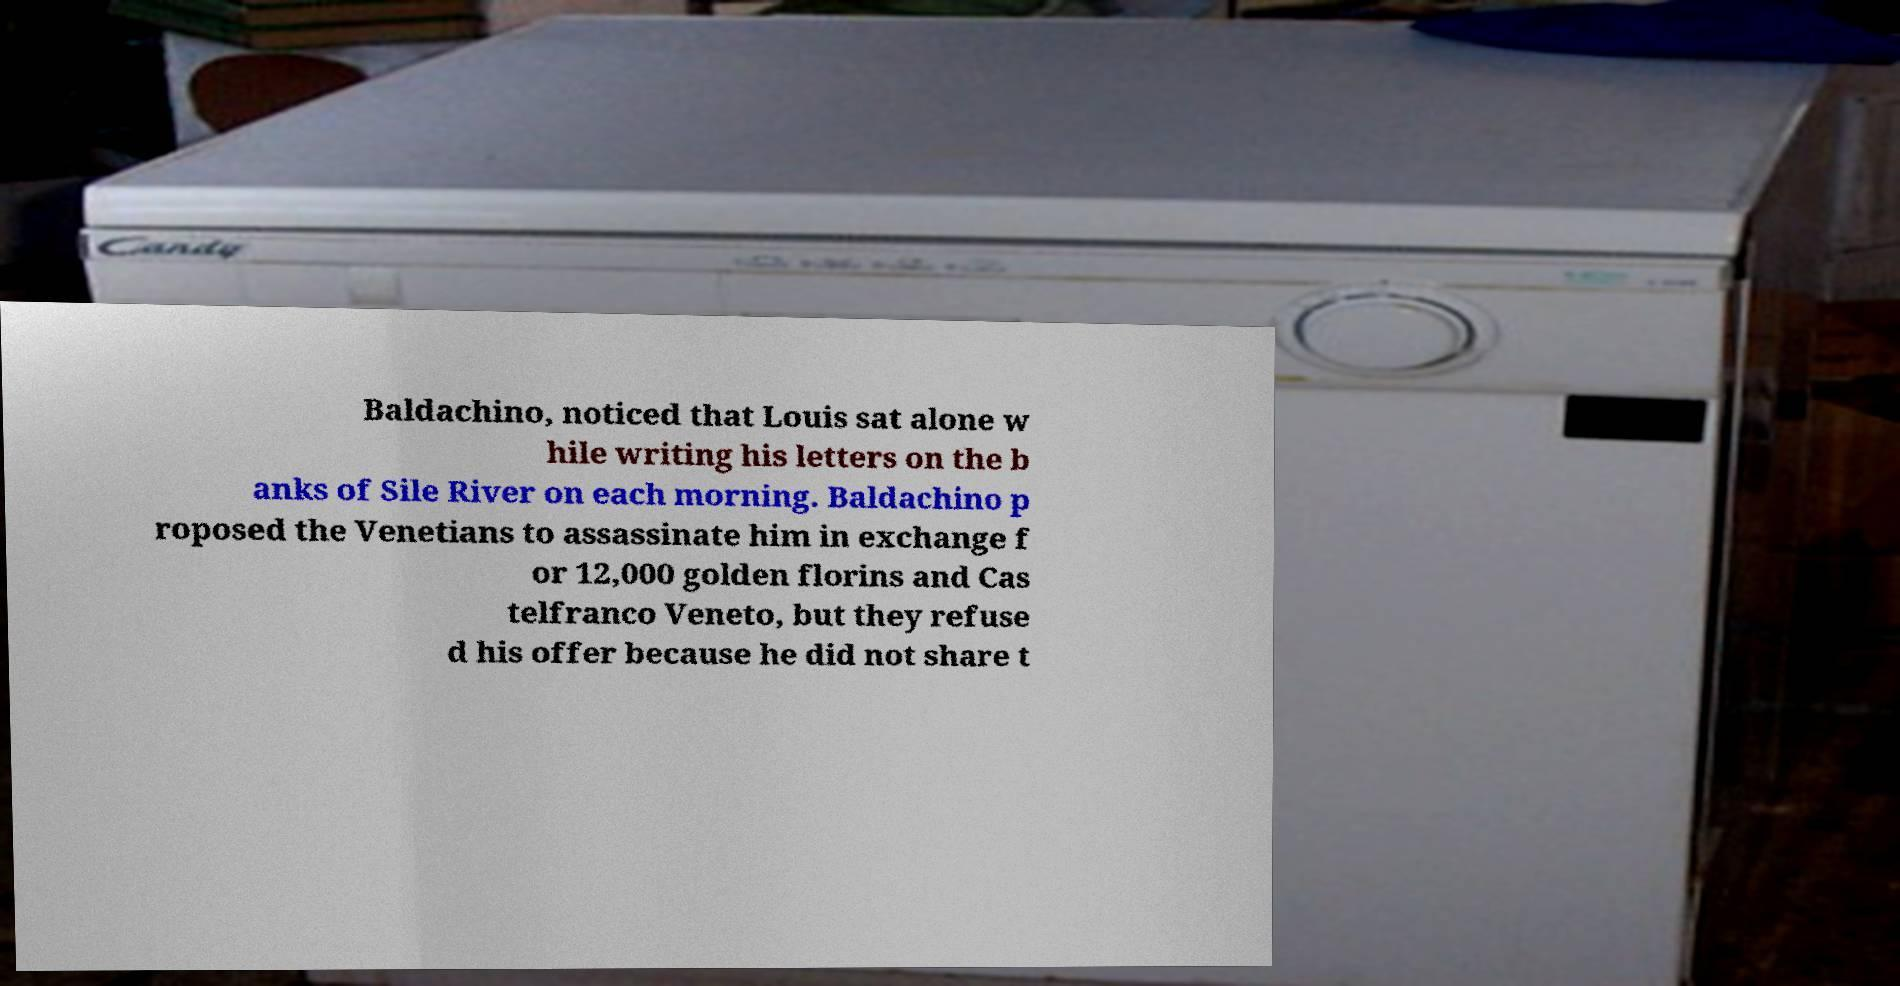I need the written content from this picture converted into text. Can you do that? Baldachino, noticed that Louis sat alone w hile writing his letters on the b anks of Sile River on each morning. Baldachino p roposed the Venetians to assassinate him in exchange f or 12,000 golden florins and Cas telfranco Veneto, but they refuse d his offer because he did not share t 